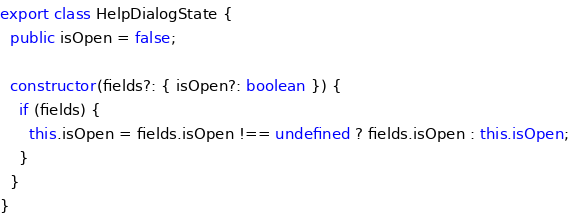<code> <loc_0><loc_0><loc_500><loc_500><_TypeScript_>export class HelpDialogState {
  public isOpen = false;

  constructor(fields?: { isOpen?: boolean }) {
    if (fields) {
      this.isOpen = fields.isOpen !== undefined ? fields.isOpen : this.isOpen;
    }
  }
}
</code> 